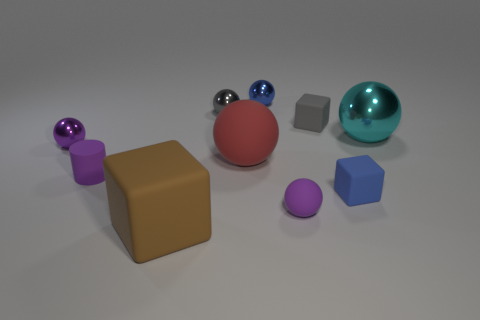Which shapes are present in the image? In the image, there are spheres, cubes, and what appears to be a rectangular prism. The spheres come in various sizes and colors, the cubes are smaller and have different colors, and the rectangular prism is notably larger than the other shapes, and has a tan color. 